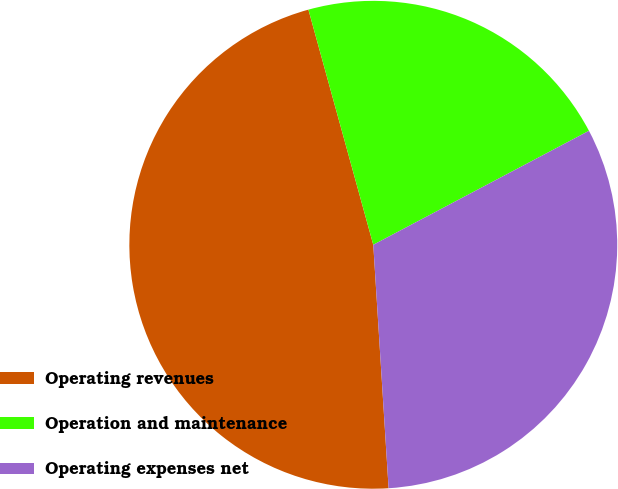Convert chart. <chart><loc_0><loc_0><loc_500><loc_500><pie_chart><fcel>Operating revenues<fcel>Operation and maintenance<fcel>Operating expenses net<nl><fcel>46.72%<fcel>21.55%<fcel>31.74%<nl></chart> 